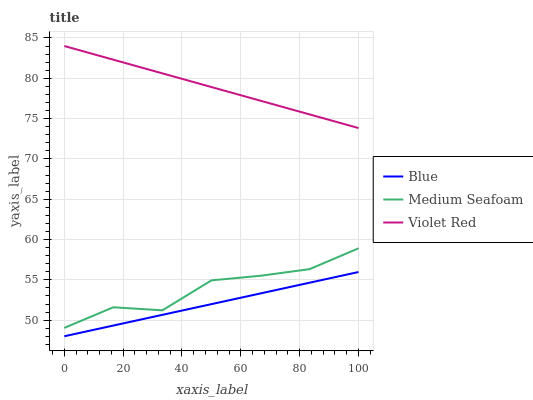Does Medium Seafoam have the minimum area under the curve?
Answer yes or no. No. Does Medium Seafoam have the maximum area under the curve?
Answer yes or no. No. Is Violet Red the smoothest?
Answer yes or no. No. Is Violet Red the roughest?
Answer yes or no. No. Does Medium Seafoam have the lowest value?
Answer yes or no. No. Does Medium Seafoam have the highest value?
Answer yes or no. No. Is Blue less than Medium Seafoam?
Answer yes or no. Yes. Is Medium Seafoam greater than Blue?
Answer yes or no. Yes. Does Blue intersect Medium Seafoam?
Answer yes or no. No. 